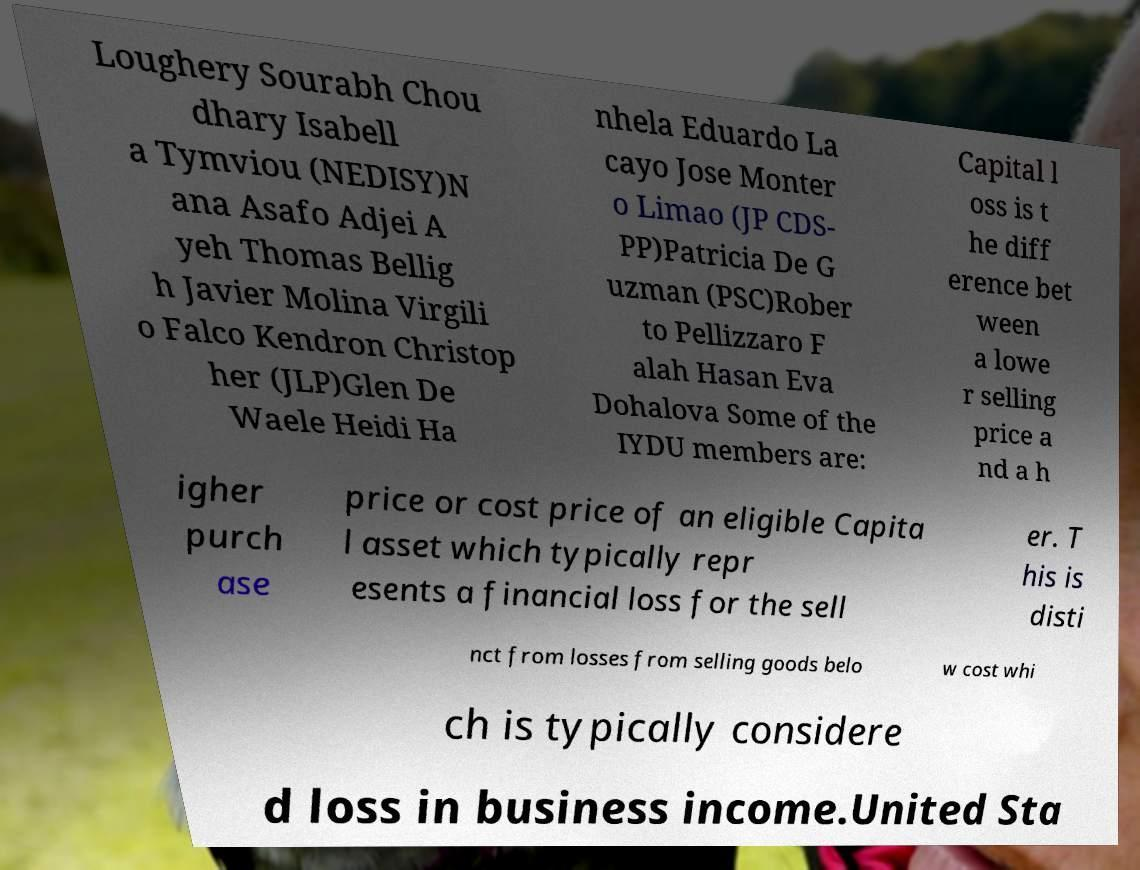For documentation purposes, I need the text within this image transcribed. Could you provide that? Loughery Sourabh Chou dhary Isabell a Tymviou (NEDISY)N ana Asafo Adjei A yeh Thomas Bellig h Javier Molina Virgili o Falco Kendron Christop her (JLP)Glen De Waele Heidi Ha nhela Eduardo La cayo Jose Monter o Limao (JP CDS- PP)Patricia De G uzman (PSC)Rober to Pellizzaro F alah Hasan Eva Dohalova Some of the IYDU members are: Capital l oss is t he diff erence bet ween a lowe r selling price a nd a h igher purch ase price or cost price of an eligible Capita l asset which typically repr esents a financial loss for the sell er. T his is disti nct from losses from selling goods belo w cost whi ch is typically considere d loss in business income.United Sta 